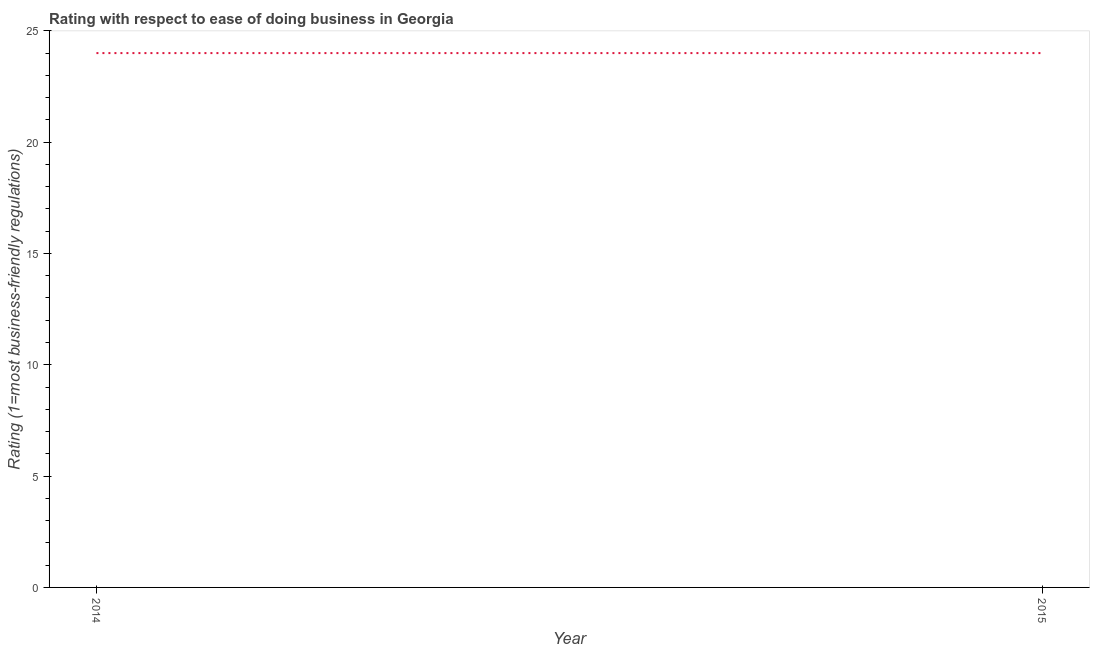What is the ease of doing business index in 2015?
Your response must be concise. 24. Across all years, what is the maximum ease of doing business index?
Make the answer very short. 24. Across all years, what is the minimum ease of doing business index?
Your answer should be compact. 24. In which year was the ease of doing business index maximum?
Provide a short and direct response. 2014. In which year was the ease of doing business index minimum?
Offer a very short reply. 2014. What is the sum of the ease of doing business index?
Ensure brevity in your answer.  48. What is the median ease of doing business index?
Give a very brief answer. 24. In how many years, is the ease of doing business index greater than 19 ?
Your response must be concise. 2. Do a majority of the years between 2015 and 2014 (inclusive) have ease of doing business index greater than 13 ?
Ensure brevity in your answer.  No. In how many years, is the ease of doing business index greater than the average ease of doing business index taken over all years?
Provide a short and direct response. 0. Does the ease of doing business index monotonically increase over the years?
Your answer should be very brief. No. How many years are there in the graph?
Make the answer very short. 2. Are the values on the major ticks of Y-axis written in scientific E-notation?
Keep it short and to the point. No. Does the graph contain any zero values?
Your response must be concise. No. Does the graph contain grids?
Offer a very short reply. No. What is the title of the graph?
Provide a short and direct response. Rating with respect to ease of doing business in Georgia. What is the label or title of the X-axis?
Provide a succinct answer. Year. What is the label or title of the Y-axis?
Ensure brevity in your answer.  Rating (1=most business-friendly regulations). What is the Rating (1=most business-friendly regulations) in 2014?
Provide a succinct answer. 24. What is the ratio of the Rating (1=most business-friendly regulations) in 2014 to that in 2015?
Provide a succinct answer. 1. 